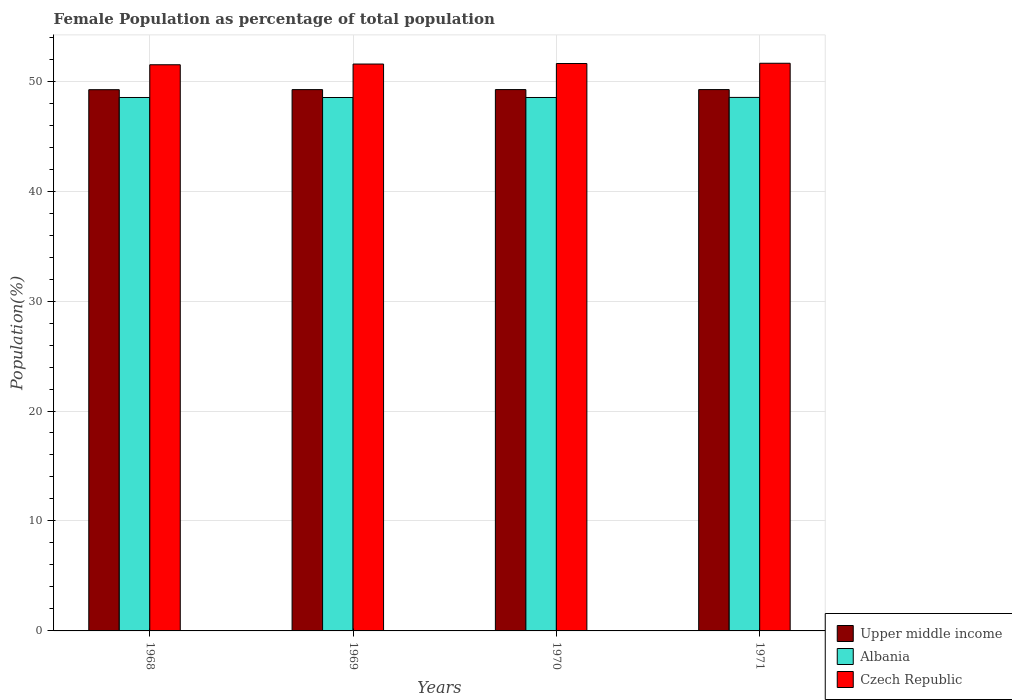How many different coloured bars are there?
Your answer should be very brief. 3. Are the number of bars per tick equal to the number of legend labels?
Provide a short and direct response. Yes. Are the number of bars on each tick of the X-axis equal?
Offer a terse response. Yes. How many bars are there on the 2nd tick from the right?
Your answer should be very brief. 3. What is the label of the 1st group of bars from the left?
Keep it short and to the point. 1968. In how many cases, is the number of bars for a given year not equal to the number of legend labels?
Offer a terse response. 0. What is the female population in in Albania in 1968?
Your response must be concise. 48.51. Across all years, what is the maximum female population in in Albania?
Keep it short and to the point. 48.52. Across all years, what is the minimum female population in in Albania?
Offer a very short reply. 48.51. In which year was the female population in in Upper middle income maximum?
Make the answer very short. 1971. In which year was the female population in in Upper middle income minimum?
Offer a very short reply. 1968. What is the total female population in in Czech Republic in the graph?
Ensure brevity in your answer.  206.27. What is the difference between the female population in in Czech Republic in 1970 and that in 1971?
Ensure brevity in your answer.  -0.02. What is the difference between the female population in in Albania in 1968 and the female population in in Upper middle income in 1971?
Provide a short and direct response. -0.72. What is the average female population in in Czech Republic per year?
Offer a terse response. 51.57. In the year 1971, what is the difference between the female population in in Upper middle income and female population in in Albania?
Give a very brief answer. 0.71. In how many years, is the female population in in Albania greater than 18 %?
Offer a terse response. 4. What is the ratio of the female population in in Upper middle income in 1968 to that in 1970?
Provide a succinct answer. 1. Is the female population in in Czech Republic in 1968 less than that in 1969?
Your response must be concise. Yes. What is the difference between the highest and the second highest female population in in Upper middle income?
Keep it short and to the point. 0. What is the difference between the highest and the lowest female population in in Albania?
Offer a very short reply. 0.01. In how many years, is the female population in in Upper middle income greater than the average female population in in Upper middle income taken over all years?
Give a very brief answer. 2. What does the 3rd bar from the left in 1969 represents?
Make the answer very short. Czech Republic. What does the 2nd bar from the right in 1970 represents?
Make the answer very short. Albania. Is it the case that in every year, the sum of the female population in in Upper middle income and female population in in Czech Republic is greater than the female population in in Albania?
Keep it short and to the point. Yes. How many bars are there?
Provide a succinct answer. 12. How many legend labels are there?
Make the answer very short. 3. What is the title of the graph?
Provide a succinct answer. Female Population as percentage of total population. What is the label or title of the Y-axis?
Ensure brevity in your answer.  Population(%). What is the Population(%) in Upper middle income in 1968?
Offer a terse response. 49.22. What is the Population(%) in Albania in 1968?
Your response must be concise. 48.51. What is the Population(%) of Czech Republic in 1968?
Give a very brief answer. 51.49. What is the Population(%) of Upper middle income in 1969?
Provide a succinct answer. 49.23. What is the Population(%) of Albania in 1969?
Provide a succinct answer. 48.51. What is the Population(%) of Czech Republic in 1969?
Provide a succinct answer. 51.55. What is the Population(%) of Upper middle income in 1970?
Ensure brevity in your answer.  49.23. What is the Population(%) of Albania in 1970?
Your answer should be compact. 48.51. What is the Population(%) of Czech Republic in 1970?
Your answer should be very brief. 51.6. What is the Population(%) of Upper middle income in 1971?
Your answer should be very brief. 49.23. What is the Population(%) in Albania in 1971?
Provide a succinct answer. 48.52. What is the Population(%) in Czech Republic in 1971?
Ensure brevity in your answer.  51.62. Across all years, what is the maximum Population(%) in Upper middle income?
Offer a terse response. 49.23. Across all years, what is the maximum Population(%) of Albania?
Your response must be concise. 48.52. Across all years, what is the maximum Population(%) of Czech Republic?
Offer a terse response. 51.62. Across all years, what is the minimum Population(%) of Upper middle income?
Give a very brief answer. 49.22. Across all years, what is the minimum Population(%) of Albania?
Provide a short and direct response. 48.51. Across all years, what is the minimum Population(%) of Czech Republic?
Your response must be concise. 51.49. What is the total Population(%) in Upper middle income in the graph?
Provide a succinct answer. 196.91. What is the total Population(%) in Albania in the graph?
Provide a short and direct response. 194.05. What is the total Population(%) of Czech Republic in the graph?
Offer a very short reply. 206.27. What is the difference between the Population(%) in Upper middle income in 1968 and that in 1969?
Give a very brief answer. -0.01. What is the difference between the Population(%) in Albania in 1968 and that in 1969?
Offer a very short reply. 0. What is the difference between the Population(%) in Czech Republic in 1968 and that in 1969?
Your answer should be compact. -0.07. What is the difference between the Population(%) in Upper middle income in 1968 and that in 1970?
Offer a terse response. -0.01. What is the difference between the Population(%) in Albania in 1968 and that in 1970?
Offer a very short reply. -0. What is the difference between the Population(%) of Czech Republic in 1968 and that in 1970?
Your answer should be very brief. -0.11. What is the difference between the Population(%) of Upper middle income in 1968 and that in 1971?
Provide a succinct answer. -0.01. What is the difference between the Population(%) in Albania in 1968 and that in 1971?
Offer a very short reply. -0.01. What is the difference between the Population(%) in Czech Republic in 1968 and that in 1971?
Your answer should be very brief. -0.14. What is the difference between the Population(%) of Upper middle income in 1969 and that in 1970?
Offer a very short reply. -0. What is the difference between the Population(%) of Albania in 1969 and that in 1970?
Your answer should be compact. -0. What is the difference between the Population(%) of Czech Republic in 1969 and that in 1970?
Offer a terse response. -0.05. What is the difference between the Population(%) in Upper middle income in 1969 and that in 1971?
Offer a terse response. -0. What is the difference between the Population(%) of Albania in 1969 and that in 1971?
Make the answer very short. -0.01. What is the difference between the Population(%) of Czech Republic in 1969 and that in 1971?
Provide a short and direct response. -0.07. What is the difference between the Population(%) of Upper middle income in 1970 and that in 1971?
Offer a terse response. -0. What is the difference between the Population(%) of Albania in 1970 and that in 1971?
Your answer should be compact. -0.01. What is the difference between the Population(%) in Czech Republic in 1970 and that in 1971?
Your response must be concise. -0.02. What is the difference between the Population(%) in Upper middle income in 1968 and the Population(%) in Albania in 1969?
Your answer should be compact. 0.71. What is the difference between the Population(%) of Upper middle income in 1968 and the Population(%) of Czech Republic in 1969?
Your answer should be very brief. -2.33. What is the difference between the Population(%) of Albania in 1968 and the Population(%) of Czech Republic in 1969?
Make the answer very short. -3.04. What is the difference between the Population(%) in Upper middle income in 1968 and the Population(%) in Albania in 1970?
Offer a very short reply. 0.71. What is the difference between the Population(%) in Upper middle income in 1968 and the Population(%) in Czech Republic in 1970?
Keep it short and to the point. -2.38. What is the difference between the Population(%) in Albania in 1968 and the Population(%) in Czech Republic in 1970?
Ensure brevity in your answer.  -3.09. What is the difference between the Population(%) in Upper middle income in 1968 and the Population(%) in Albania in 1971?
Offer a terse response. 0.7. What is the difference between the Population(%) of Upper middle income in 1968 and the Population(%) of Czech Republic in 1971?
Offer a terse response. -2.4. What is the difference between the Population(%) in Albania in 1968 and the Population(%) in Czech Republic in 1971?
Provide a succinct answer. -3.11. What is the difference between the Population(%) of Upper middle income in 1969 and the Population(%) of Albania in 1970?
Offer a very short reply. 0.72. What is the difference between the Population(%) of Upper middle income in 1969 and the Population(%) of Czech Republic in 1970?
Give a very brief answer. -2.37. What is the difference between the Population(%) of Albania in 1969 and the Population(%) of Czech Republic in 1970?
Offer a very short reply. -3.09. What is the difference between the Population(%) in Upper middle income in 1969 and the Population(%) in Albania in 1971?
Provide a short and direct response. 0.71. What is the difference between the Population(%) of Upper middle income in 1969 and the Population(%) of Czech Republic in 1971?
Provide a short and direct response. -2.4. What is the difference between the Population(%) of Albania in 1969 and the Population(%) of Czech Republic in 1971?
Offer a terse response. -3.12. What is the difference between the Population(%) in Upper middle income in 1970 and the Population(%) in Albania in 1971?
Make the answer very short. 0.71. What is the difference between the Population(%) in Upper middle income in 1970 and the Population(%) in Czech Republic in 1971?
Ensure brevity in your answer.  -2.39. What is the difference between the Population(%) of Albania in 1970 and the Population(%) of Czech Republic in 1971?
Keep it short and to the point. -3.11. What is the average Population(%) of Upper middle income per year?
Provide a succinct answer. 49.23. What is the average Population(%) in Albania per year?
Your response must be concise. 48.51. What is the average Population(%) of Czech Republic per year?
Your answer should be very brief. 51.57. In the year 1968, what is the difference between the Population(%) in Upper middle income and Population(%) in Albania?
Offer a terse response. 0.71. In the year 1968, what is the difference between the Population(%) in Upper middle income and Population(%) in Czech Republic?
Your response must be concise. -2.27. In the year 1968, what is the difference between the Population(%) in Albania and Population(%) in Czech Republic?
Your response must be concise. -2.98. In the year 1969, what is the difference between the Population(%) in Upper middle income and Population(%) in Albania?
Your answer should be compact. 0.72. In the year 1969, what is the difference between the Population(%) in Upper middle income and Population(%) in Czech Republic?
Your response must be concise. -2.33. In the year 1969, what is the difference between the Population(%) of Albania and Population(%) of Czech Republic?
Provide a short and direct response. -3.05. In the year 1970, what is the difference between the Population(%) in Upper middle income and Population(%) in Albania?
Your answer should be very brief. 0.72. In the year 1970, what is the difference between the Population(%) in Upper middle income and Population(%) in Czech Republic?
Your answer should be very brief. -2.37. In the year 1970, what is the difference between the Population(%) in Albania and Population(%) in Czech Republic?
Provide a succinct answer. -3.09. In the year 1971, what is the difference between the Population(%) in Upper middle income and Population(%) in Albania?
Make the answer very short. 0.71. In the year 1971, what is the difference between the Population(%) in Upper middle income and Population(%) in Czech Republic?
Make the answer very short. -2.39. In the year 1971, what is the difference between the Population(%) in Albania and Population(%) in Czech Republic?
Your answer should be compact. -3.11. What is the ratio of the Population(%) in Upper middle income in 1968 to that in 1969?
Provide a short and direct response. 1. What is the ratio of the Population(%) in Albania in 1968 to that in 1969?
Offer a very short reply. 1. What is the ratio of the Population(%) of Upper middle income in 1968 to that in 1970?
Make the answer very short. 1. What is the ratio of the Population(%) in Czech Republic in 1968 to that in 1970?
Offer a terse response. 1. What is the ratio of the Population(%) in Albania in 1968 to that in 1971?
Your answer should be compact. 1. What is the ratio of the Population(%) of Upper middle income in 1969 to that in 1970?
Give a very brief answer. 1. What is the ratio of the Population(%) in Albania in 1969 to that in 1970?
Offer a terse response. 1. What is the ratio of the Population(%) of Czech Republic in 1969 to that in 1970?
Ensure brevity in your answer.  1. What is the ratio of the Population(%) of Upper middle income in 1969 to that in 1971?
Make the answer very short. 1. What is the ratio of the Population(%) in Albania in 1969 to that in 1971?
Your response must be concise. 1. What is the ratio of the Population(%) of Czech Republic in 1969 to that in 1971?
Keep it short and to the point. 1. What is the ratio of the Population(%) in Upper middle income in 1970 to that in 1971?
Ensure brevity in your answer.  1. What is the difference between the highest and the second highest Population(%) of Albania?
Provide a short and direct response. 0.01. What is the difference between the highest and the second highest Population(%) in Czech Republic?
Your response must be concise. 0.02. What is the difference between the highest and the lowest Population(%) in Upper middle income?
Your answer should be compact. 0.01. What is the difference between the highest and the lowest Population(%) of Albania?
Offer a very short reply. 0.01. What is the difference between the highest and the lowest Population(%) in Czech Republic?
Provide a succinct answer. 0.14. 